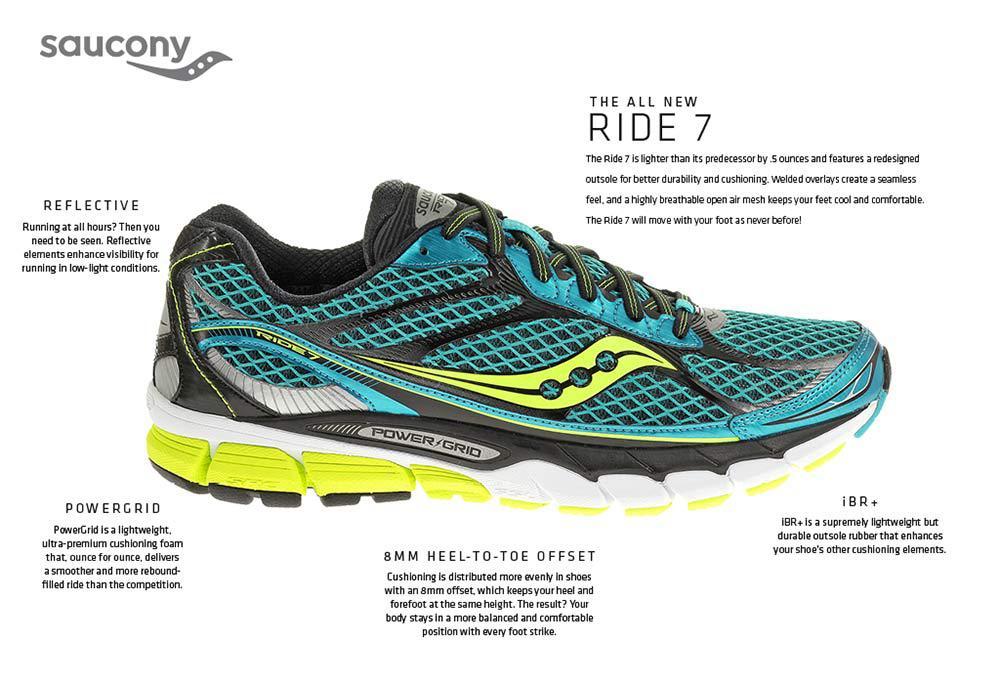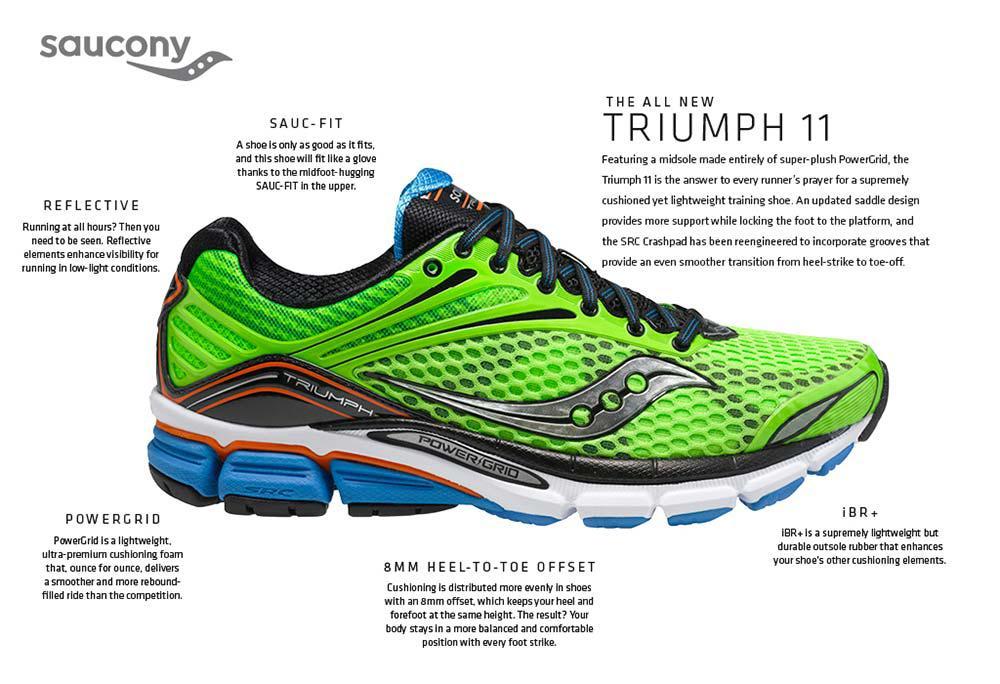The first image is the image on the left, the second image is the image on the right. Analyze the images presented: Is the assertion "Each image shows a single rightward-facing sneaker, and the combined images include lime green and aqua-blue colors, among others." valid? Answer yes or no. Yes. The first image is the image on the left, the second image is the image on the right. Analyze the images presented: Is the assertion "The shoes in each of the images have their toes facing the right." valid? Answer yes or no. Yes. 